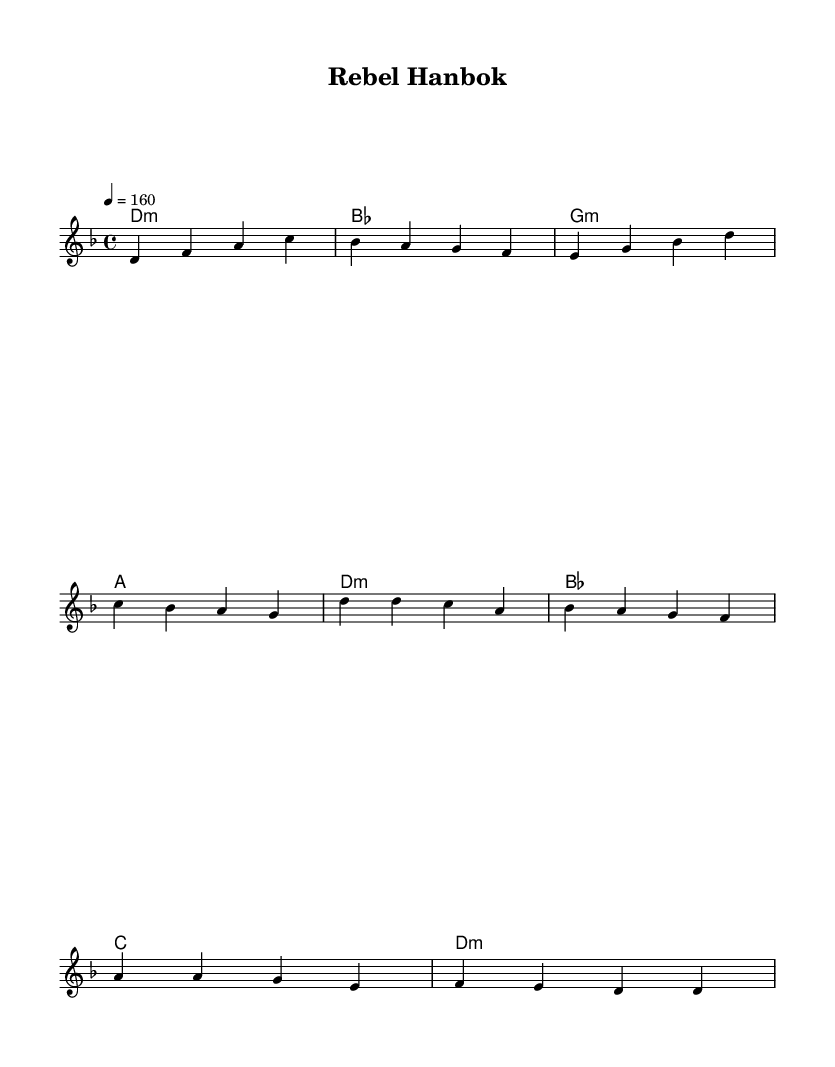What is the key signature of this music? The key signature is D minor, indicated by the two flats (B♭ and E♭) before the main staff.
Answer: D minor What is the time signature of this music? The time signature is 4/4, which indicates four beats per measure and a quarter note gets one beat. This is noted in the top left corner of the sheet music.
Answer: 4/4 What is the tempo marking in this piece? The tempo marking is 4 = 160, meaning there are 160 beats per minute and each beat is a quarter note. This information is found above the staff.
Answer: 160 How many measures are in the verse section? The verse consists of four measures, which can be counted from the melody section in the first part of the score.
Answer: 4 What is the first chord in the piece? The first chord indicated in the harmonies section is D minor, labeled as "d1:m." It is located at the beginning of the verses.
Answer: D minor Which musical form is predominantly represented in this sheet music? The music shows a structure of verse and chorus, where the verse is followed by the chorus, demonstrating a common form in K-Pop music.
Answer: Verse and Chorus What genre does the music blend according to the score? The music blends punk rock with Korean folk, as indicated by the title "Rebel Hanbok" and the stylistic elements inferred from the musical choices.
Answer: Punk rock and Korean folk 